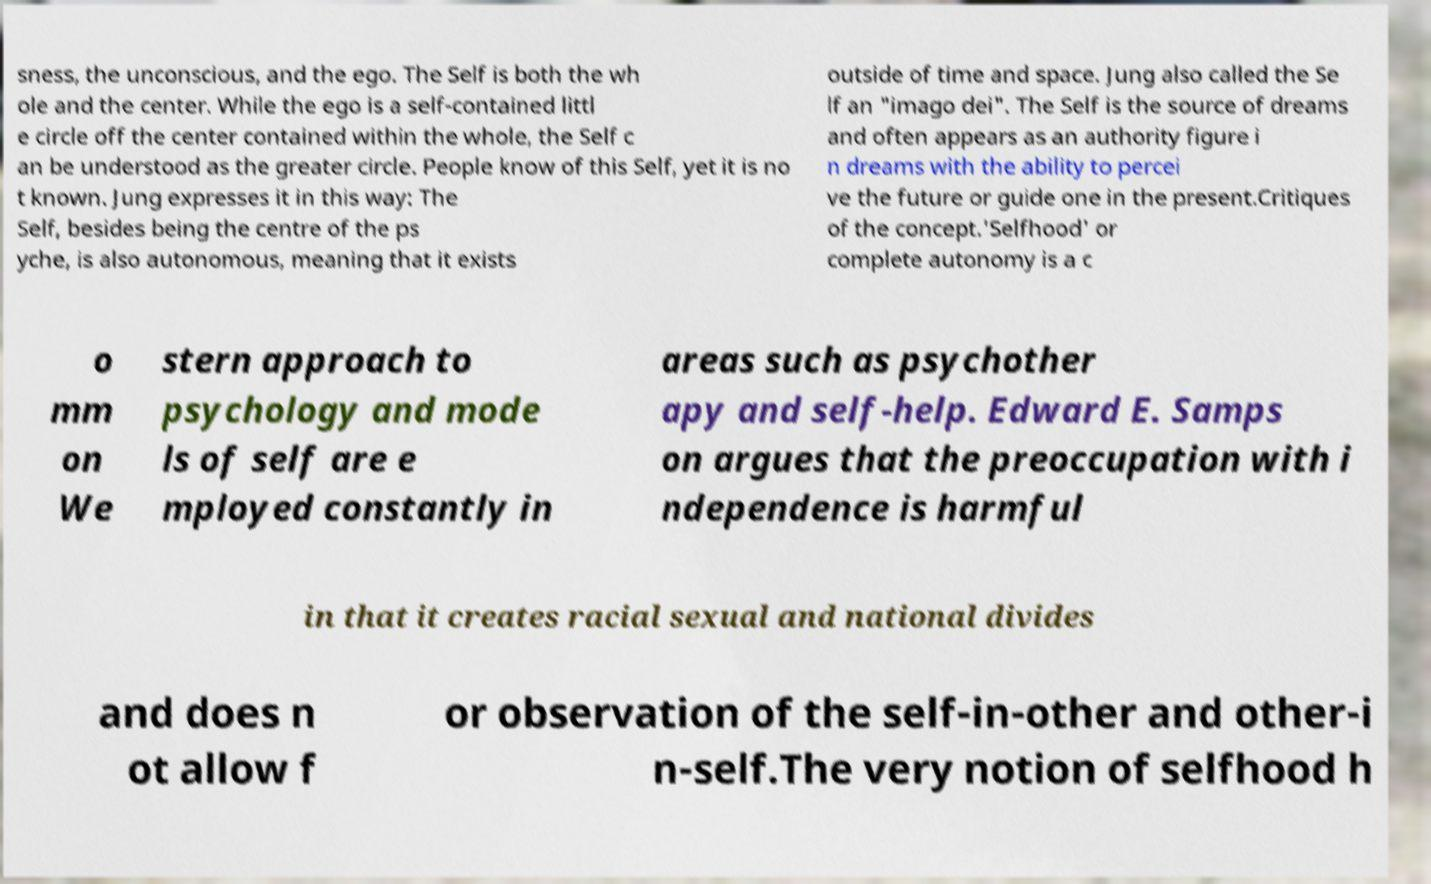Could you assist in decoding the text presented in this image and type it out clearly? sness, the unconscious, and the ego. The Self is both the wh ole and the center. While the ego is a self-contained littl e circle off the center contained within the whole, the Self c an be understood as the greater circle. People know of this Self, yet it is no t known. Jung expresses it in this way: The Self, besides being the centre of the ps yche, is also autonomous, meaning that it exists outside of time and space. Jung also called the Se lf an "imago dei". The Self is the source of dreams and often appears as an authority figure i n dreams with the ability to percei ve the future or guide one in the present.Critiques of the concept.'Selfhood' or complete autonomy is a c o mm on We stern approach to psychology and mode ls of self are e mployed constantly in areas such as psychother apy and self-help. Edward E. Samps on argues that the preoccupation with i ndependence is harmful in that it creates racial sexual and national divides and does n ot allow f or observation of the self-in-other and other-i n-self.The very notion of selfhood h 